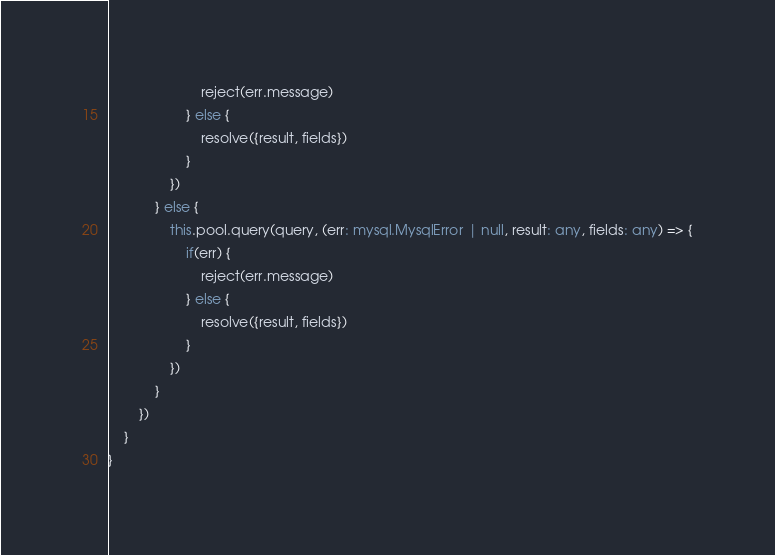Convert code to text. <code><loc_0><loc_0><loc_500><loc_500><_TypeScript_>                        reject(err.message)
                    } else {
                        resolve({result, fields})
                    }
                })
            } else {
                this.pool.query(query, (err: mysql.MysqlError | null, result: any, fields: any) => {
                    if(err) {
                        reject(err.message)
                    } else {
                        resolve({result, fields})
                    }
                })
            }
        })
    }
}</code> 